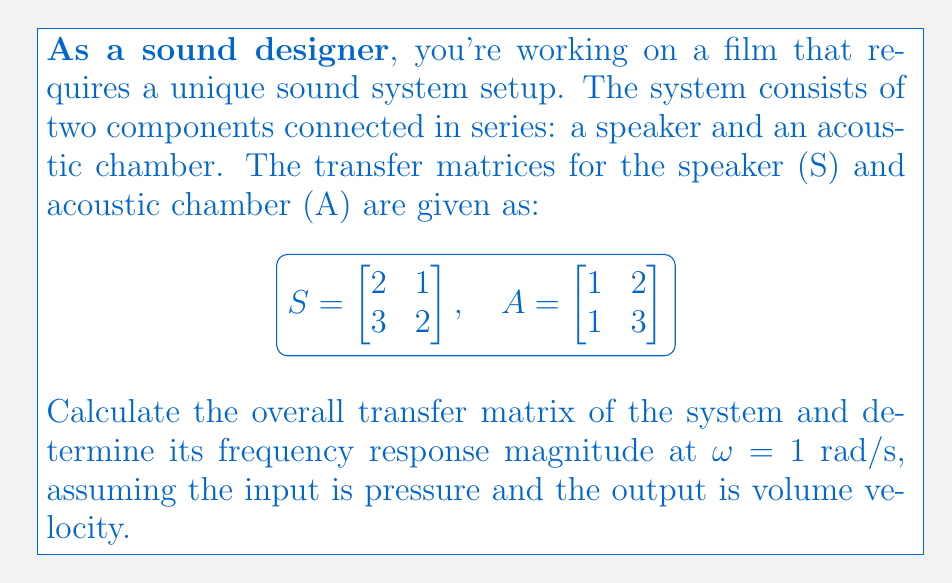What is the answer to this math problem? Let's approach this step-by-step:

1) First, we need to calculate the overall transfer matrix of the system. In a series connection, we multiply the individual transfer matrices in the order they appear in the signal chain. The overall transfer matrix T is:

   $$T = A \cdot S = \begin{bmatrix} 1 & 2 \\ 1 & 3 \end{bmatrix} \cdot \begin{bmatrix} 2 & 1 \\ 3 & 2 \end{bmatrix}$$

2) Multiplying these matrices:

   $$T = \begin{bmatrix} (1\cdot2 + 2\cdot3) & (1\cdot1 + 2\cdot2) \\ (1\cdot2 + 3\cdot3) & (1\cdot1 + 3\cdot2) \end{bmatrix} = \begin{bmatrix} 8 & 5 \\ 11 & 7 \end{bmatrix}$$

3) Now, to find the frequency response, we use the formula:

   $$H(\omega) = \frac{1}{T_{11} + T_{12}/(j\omega)}$$

   Where $T_{11}$ and $T_{12}$ are elements of the transfer matrix T.

4) Substituting the values and ω = 1 rad/s:

   $$H(1) = \frac{1}{8 + 5/(j\cdot1)} = \frac{1}{8 + 5j}$$

5) To find the magnitude of the frequency response, we take the absolute value:

   $$|H(1)| = \left|\frac{1}{8 + 5j}\right| = \frac{1}{\sqrt{8^2 + 5^2}} = \frac{1}{\sqrt{89}}$$

6) Simplifying:

   $$|H(1)| = \frac{1}{9.434}$$
Answer: $\frac{1}{9.434}$ 